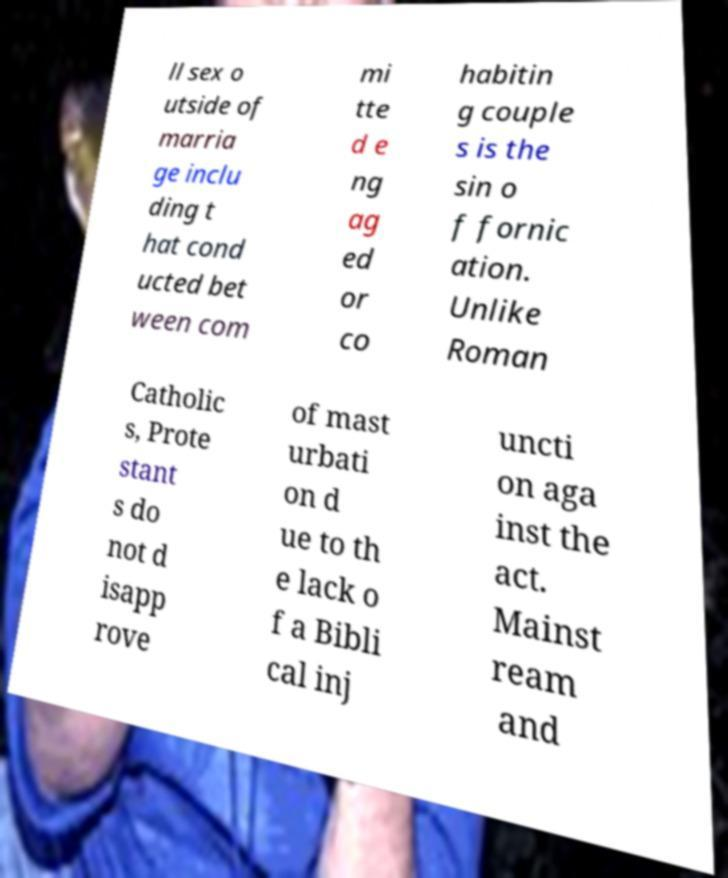Could you assist in decoding the text presented in this image and type it out clearly? ll sex o utside of marria ge inclu ding t hat cond ucted bet ween com mi tte d e ng ag ed or co habitin g couple s is the sin o f fornic ation. Unlike Roman Catholic s, Prote stant s do not d isapp rove of mast urbati on d ue to th e lack o f a Bibli cal inj uncti on aga inst the act. Mainst ream and 